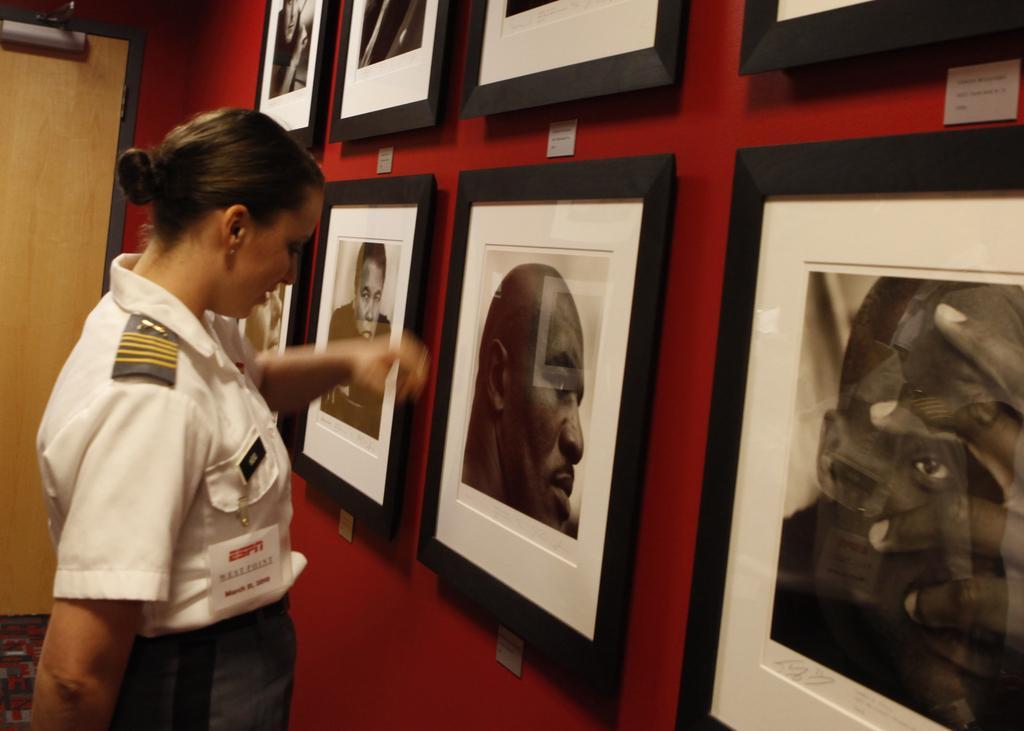Please provide a concise description of this image. In this picture we can see a woman on the left side. There are few frames on the wall. We can see a door in the background. 